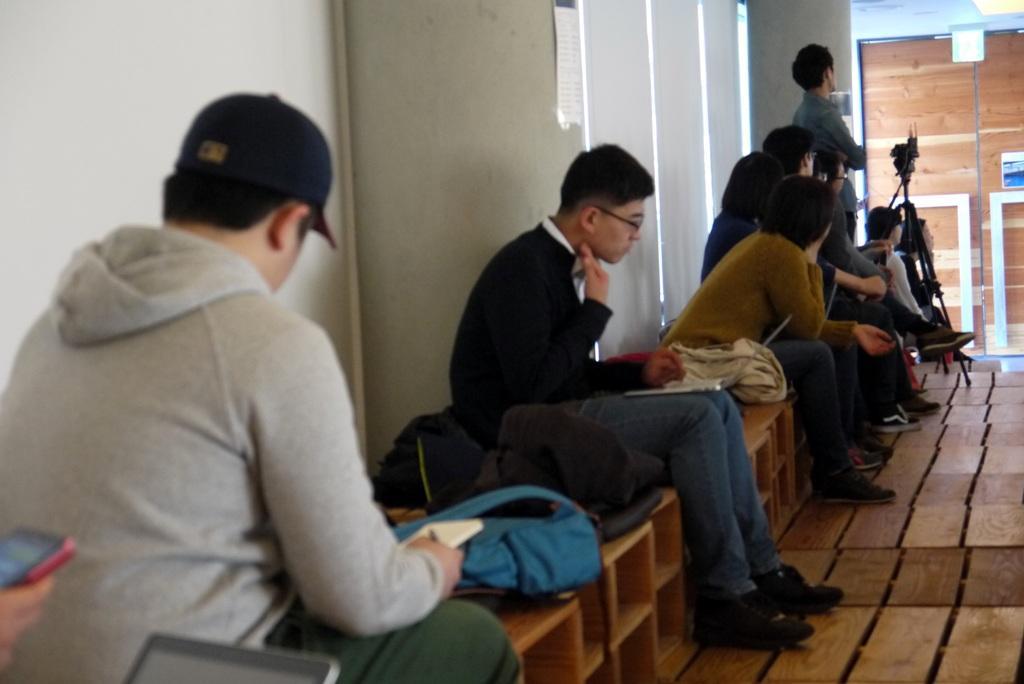Can you describe this image briefly? In this image we can see persons sitting on the benches. In the background we can see wall, camera, camera stand and light. 